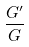<formula> <loc_0><loc_0><loc_500><loc_500>\frac { G ^ { \prime } } { G }</formula> 